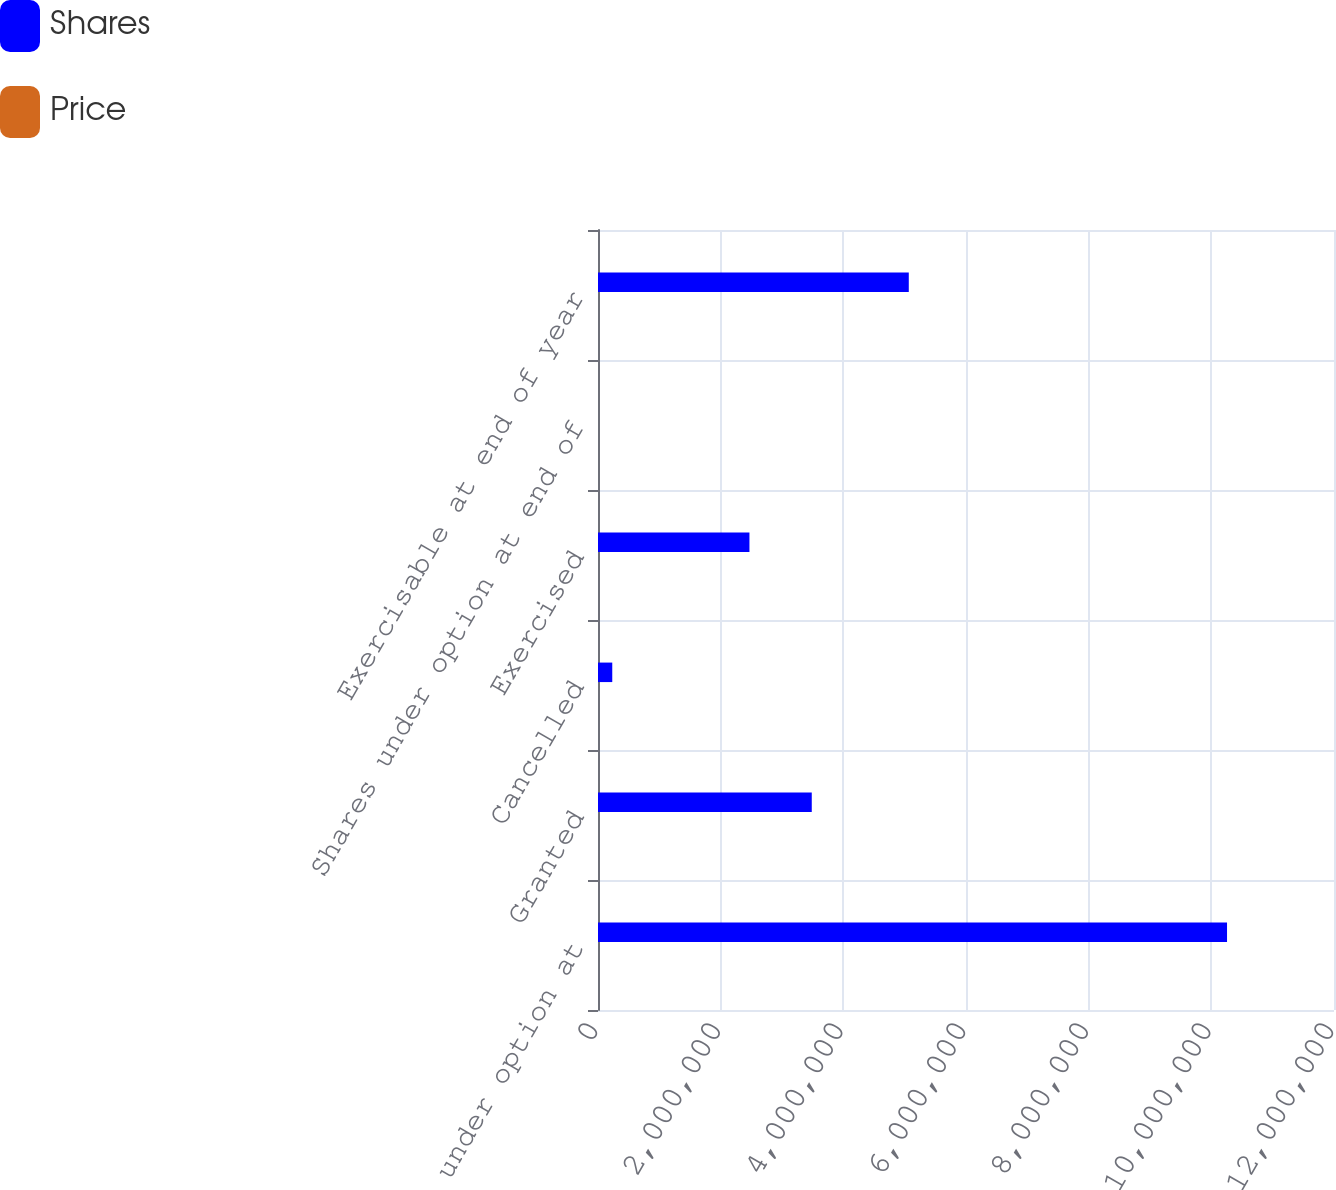Convert chart. <chart><loc_0><loc_0><loc_500><loc_500><stacked_bar_chart><ecel><fcel>Shares under option at<fcel>Granted<fcel>Cancelled<fcel>Exercised<fcel>Shares under option at end of<fcel>Exercisable at end of year<nl><fcel>Shares<fcel>1.0256e+07<fcel>3.48528e+06<fcel>232488<fcel>2.46923e+06<fcel>44.03<fcel>5.06719e+06<nl><fcel>Price<fcel>34.19<fcel>44.03<fcel>40.53<fcel>30.35<fcel>38.01<fcel>36.31<nl></chart> 